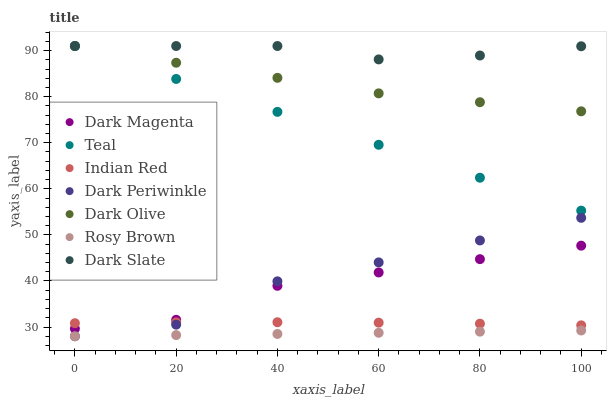Does Rosy Brown have the minimum area under the curve?
Answer yes or no. Yes. Does Dark Slate have the maximum area under the curve?
Answer yes or no. Yes. Does Dark Olive have the minimum area under the curve?
Answer yes or no. No. Does Dark Olive have the maximum area under the curve?
Answer yes or no. No. Is Rosy Brown the smoothest?
Answer yes or no. Yes. Is Dark Periwinkle the roughest?
Answer yes or no. Yes. Is Dark Olive the smoothest?
Answer yes or no. No. Is Dark Olive the roughest?
Answer yes or no. No. Does Rosy Brown have the lowest value?
Answer yes or no. Yes. Does Dark Olive have the lowest value?
Answer yes or no. No. Does Dark Slate have the highest value?
Answer yes or no. Yes. Does Dark Magenta have the highest value?
Answer yes or no. No. Is Dark Periwinkle less than Teal?
Answer yes or no. Yes. Is Dark Slate greater than Dark Periwinkle?
Answer yes or no. Yes. Does Dark Magenta intersect Dark Periwinkle?
Answer yes or no. Yes. Is Dark Magenta less than Dark Periwinkle?
Answer yes or no. No. Is Dark Magenta greater than Dark Periwinkle?
Answer yes or no. No. Does Dark Periwinkle intersect Teal?
Answer yes or no. No. 